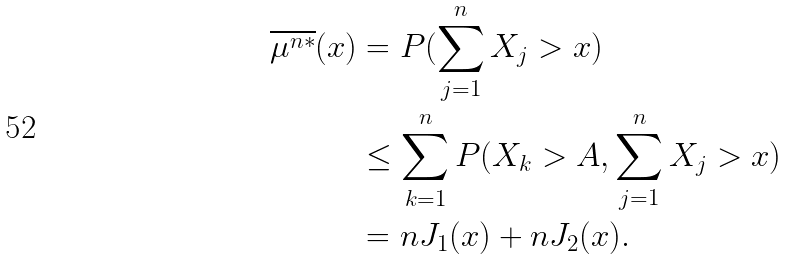Convert formula to latex. <formula><loc_0><loc_0><loc_500><loc_500>\overline { \mu ^ { n * } } ( x ) & = P ( \sum _ { j = 1 } ^ { n } X _ { j } > x ) \\ & \leq \sum _ { k = 1 } ^ { n } P ( X _ { k } > A , \sum _ { j = 1 } ^ { n } X _ { j } > x ) \\ & = n J _ { 1 } ( x ) + n J _ { 2 } ( x ) .</formula> 